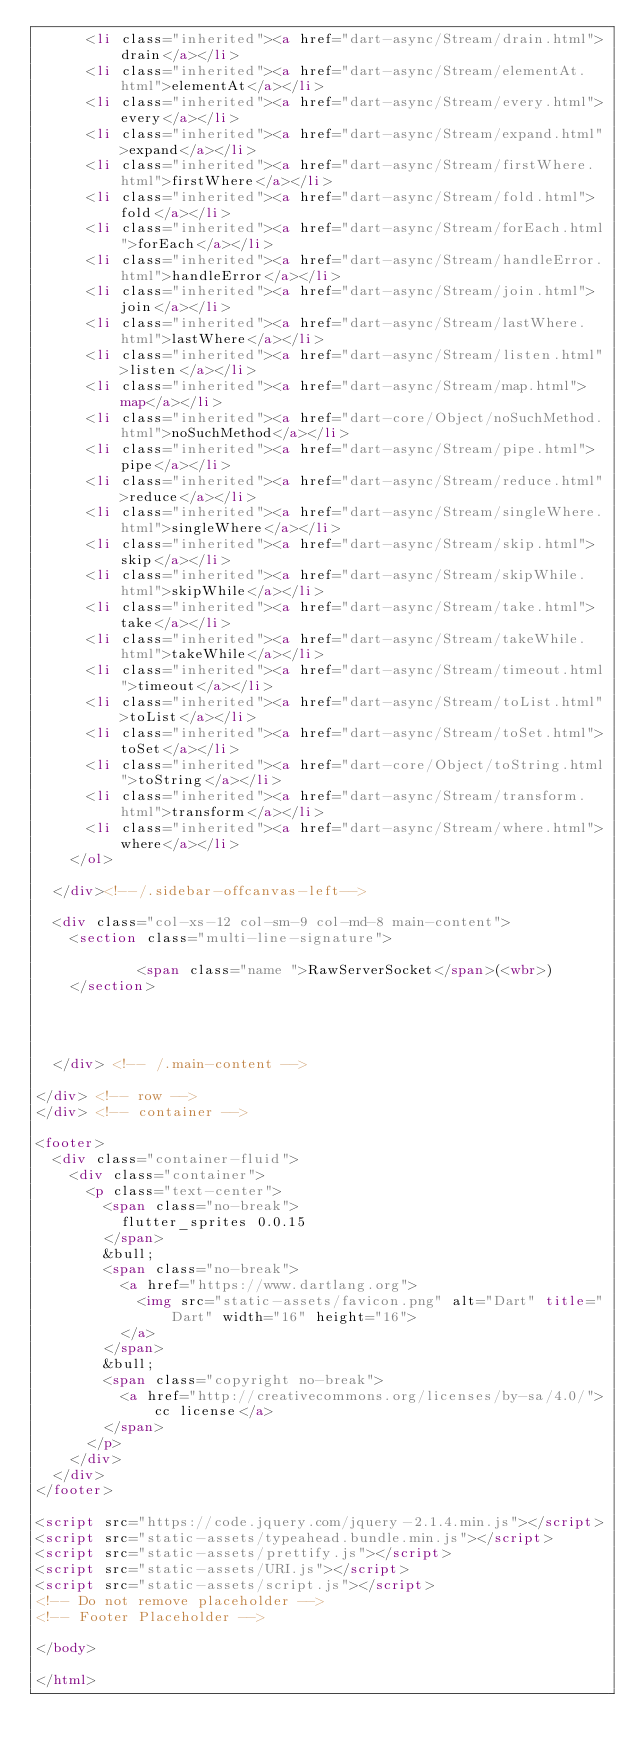Convert code to text. <code><loc_0><loc_0><loc_500><loc_500><_HTML_>      <li class="inherited"><a href="dart-async/Stream/drain.html">drain</a></li>
      <li class="inherited"><a href="dart-async/Stream/elementAt.html">elementAt</a></li>
      <li class="inherited"><a href="dart-async/Stream/every.html">every</a></li>
      <li class="inherited"><a href="dart-async/Stream/expand.html">expand</a></li>
      <li class="inherited"><a href="dart-async/Stream/firstWhere.html">firstWhere</a></li>
      <li class="inherited"><a href="dart-async/Stream/fold.html">fold</a></li>
      <li class="inherited"><a href="dart-async/Stream/forEach.html">forEach</a></li>
      <li class="inherited"><a href="dart-async/Stream/handleError.html">handleError</a></li>
      <li class="inherited"><a href="dart-async/Stream/join.html">join</a></li>
      <li class="inherited"><a href="dart-async/Stream/lastWhere.html">lastWhere</a></li>
      <li class="inherited"><a href="dart-async/Stream/listen.html">listen</a></li>
      <li class="inherited"><a href="dart-async/Stream/map.html">map</a></li>
      <li class="inherited"><a href="dart-core/Object/noSuchMethod.html">noSuchMethod</a></li>
      <li class="inherited"><a href="dart-async/Stream/pipe.html">pipe</a></li>
      <li class="inherited"><a href="dart-async/Stream/reduce.html">reduce</a></li>
      <li class="inherited"><a href="dart-async/Stream/singleWhere.html">singleWhere</a></li>
      <li class="inherited"><a href="dart-async/Stream/skip.html">skip</a></li>
      <li class="inherited"><a href="dart-async/Stream/skipWhile.html">skipWhile</a></li>
      <li class="inherited"><a href="dart-async/Stream/take.html">take</a></li>
      <li class="inherited"><a href="dart-async/Stream/takeWhile.html">takeWhile</a></li>
      <li class="inherited"><a href="dart-async/Stream/timeout.html">timeout</a></li>
      <li class="inherited"><a href="dart-async/Stream/toList.html">toList</a></li>
      <li class="inherited"><a href="dart-async/Stream/toSet.html">toSet</a></li>
      <li class="inherited"><a href="dart-core/Object/toString.html">toString</a></li>
      <li class="inherited"><a href="dart-async/Stream/transform.html">transform</a></li>
      <li class="inherited"><a href="dart-async/Stream/where.html">where</a></li>
    </ol>

  </div><!--/.sidebar-offcanvas-left-->

  <div class="col-xs-12 col-sm-9 col-md-8 main-content">
    <section class="multi-line-signature">
      
            <span class="name ">RawServerSocket</span>(<wbr>)
    </section>

    
    

  </div> <!-- /.main-content -->

</div> <!-- row -->
</div> <!-- container -->

<footer>
  <div class="container-fluid">
    <div class="container">
      <p class="text-center">
        <span class="no-break">
          flutter_sprites 0.0.15
        </span>
        &bull;
        <span class="no-break">
          <a href="https://www.dartlang.org">
            <img src="static-assets/favicon.png" alt="Dart" title="Dart" width="16" height="16">
          </a>
        </span>
        &bull;
        <span class="copyright no-break">
          <a href="http://creativecommons.org/licenses/by-sa/4.0/">cc license</a>
        </span>
      </p>
    </div>
  </div>
</footer>

<script src="https://code.jquery.com/jquery-2.1.4.min.js"></script>
<script src="static-assets/typeahead.bundle.min.js"></script>
<script src="static-assets/prettify.js"></script>
<script src="static-assets/URI.js"></script>
<script src="static-assets/script.js"></script>
<!-- Do not remove placeholder -->
<!-- Footer Placeholder -->

</body>

</html>
</code> 